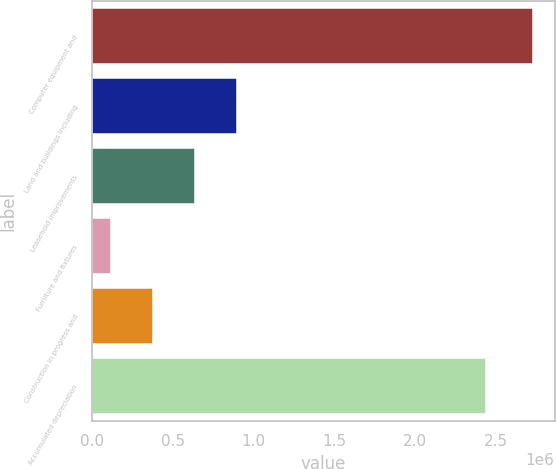Convert chart. <chart><loc_0><loc_0><loc_500><loc_500><bar_chart><fcel>Computer equipment and<fcel>Land and buildings including<fcel>Leasehold improvements<fcel>Furniture and fixtures<fcel>Construction in progress and<fcel>Accumulated depreciation<nl><fcel>2.72974e+06<fcel>899832<fcel>638418<fcel>115588<fcel>377003<fcel>2.43945e+06<nl></chart> 